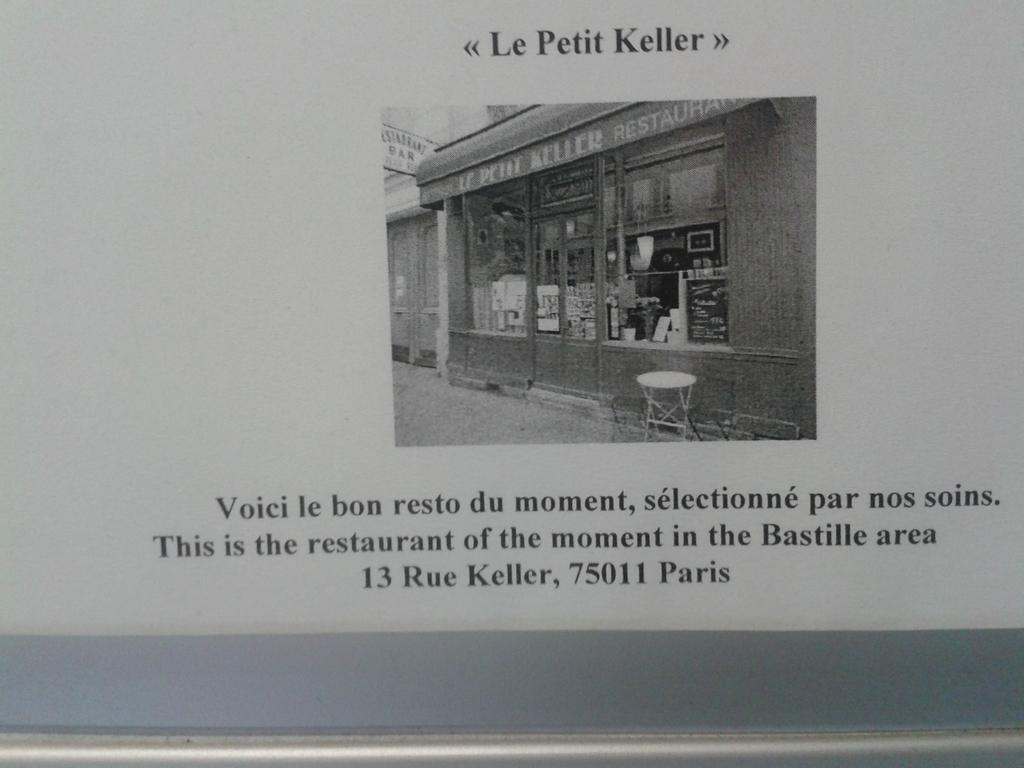What type of visual is the image? The image is a poster. What is depicted on the poster? There is a picture of a glass door on the poster. What piece of furniture is in the image? There is a stool in the image. What object is used for displaying names in the image? There is a name board in the image. What else can be seen on the poster besides the picture of the glass door? There are letters on the poster. How does the maid turn the glass door in the image? There is no maid present in the image, and the glass door is a static image on the poster. How does the person in the image sleep on the stool? There is no person sleeping on the stool in the image; it is a stool without any occupant. 